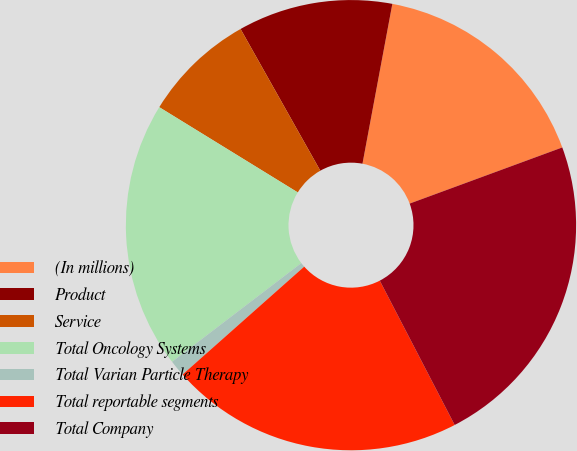Convert chart. <chart><loc_0><loc_0><loc_500><loc_500><pie_chart><fcel>(In millions)<fcel>Product<fcel>Service<fcel>Total Oncology Systems<fcel>Total Varian Particle Therapy<fcel>Total reportable segments<fcel>Total Company<nl><fcel>16.45%<fcel>11.1%<fcel>8.06%<fcel>19.16%<fcel>1.17%<fcel>21.07%<fcel>22.99%<nl></chart> 